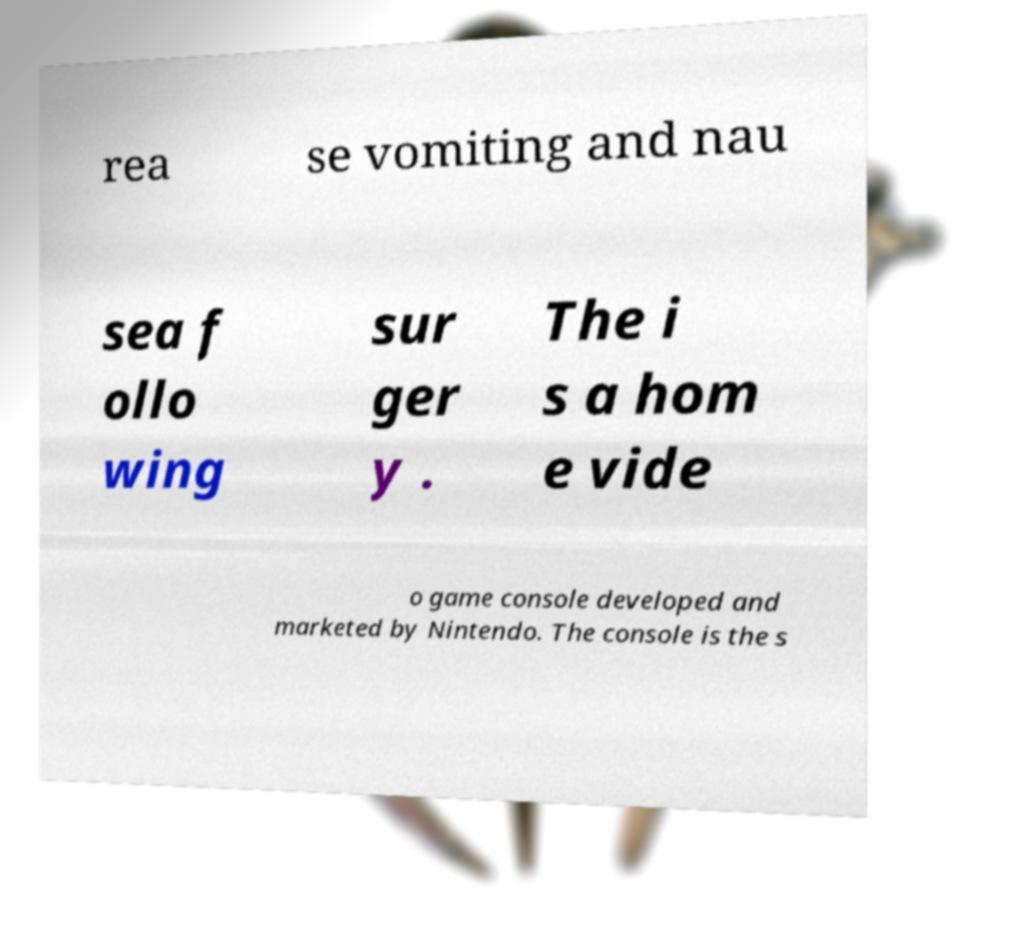There's text embedded in this image that I need extracted. Can you transcribe it verbatim? rea se vomiting and nau sea f ollo wing sur ger y . The i s a hom e vide o game console developed and marketed by Nintendo. The console is the s 